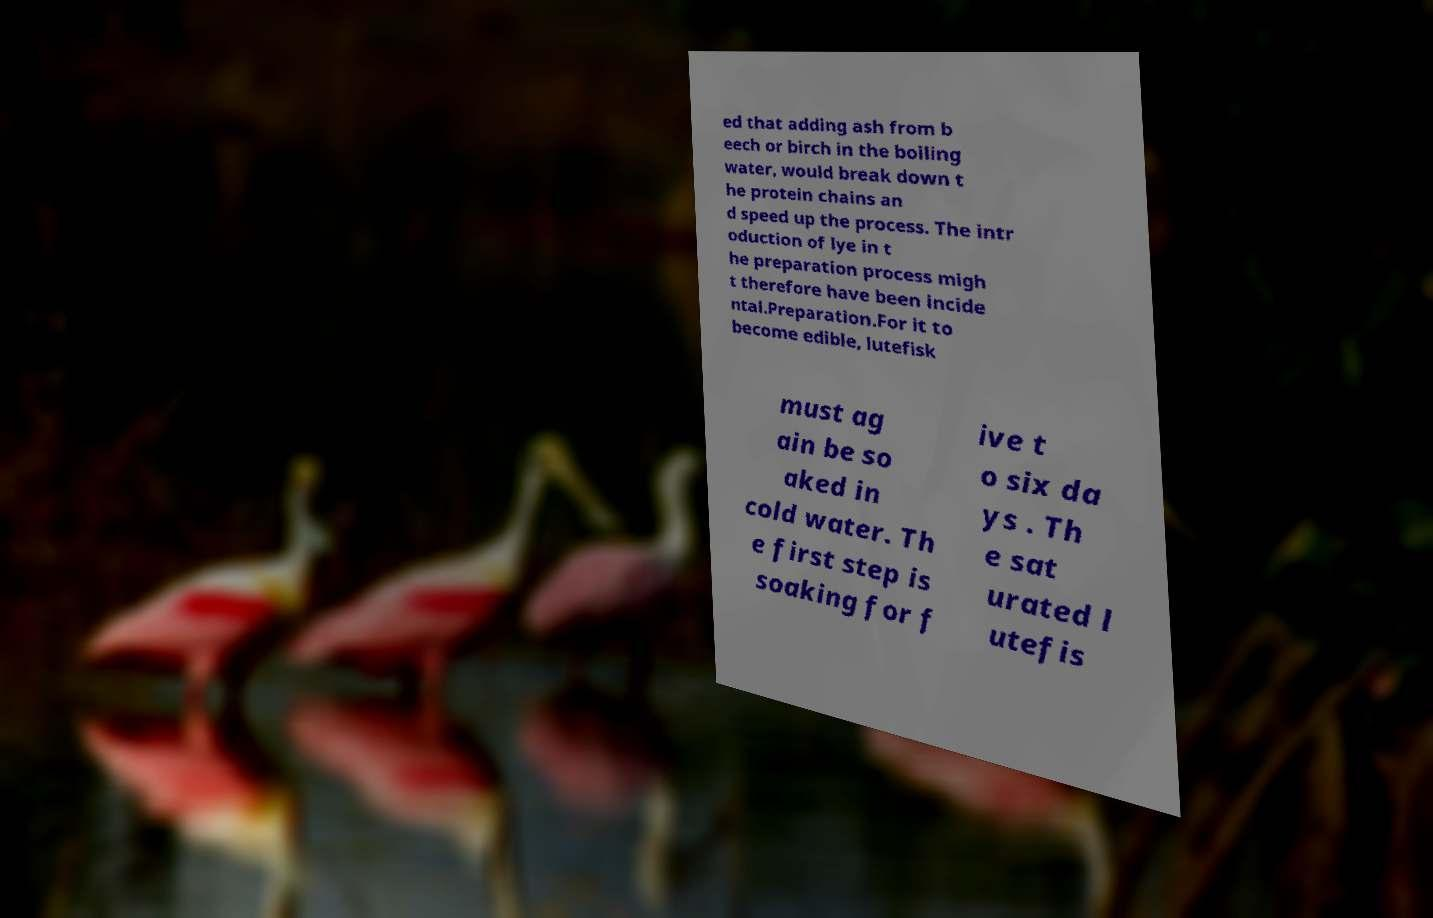Could you assist in decoding the text presented in this image and type it out clearly? ed that adding ash from b eech or birch in the boiling water, would break down t he protein chains an d speed up the process. The intr oduction of lye in t he preparation process migh t therefore have been incide ntal.Preparation.For it to become edible, lutefisk must ag ain be so aked in cold water. Th e first step is soaking for f ive t o six da ys . Th e sat urated l utefis 